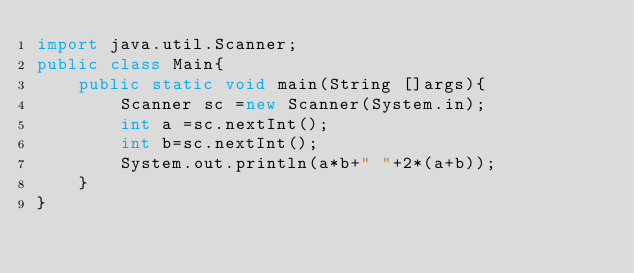Convert code to text. <code><loc_0><loc_0><loc_500><loc_500><_Java_>import java.util.Scanner;
public class Main{
    public static void main(String []args){
        Scanner sc =new Scanner(System.in);
        int a =sc.nextInt();
        int b=sc.nextInt();
        System.out.println(a*b+" "+2*(a+b));
    }
}
</code> 